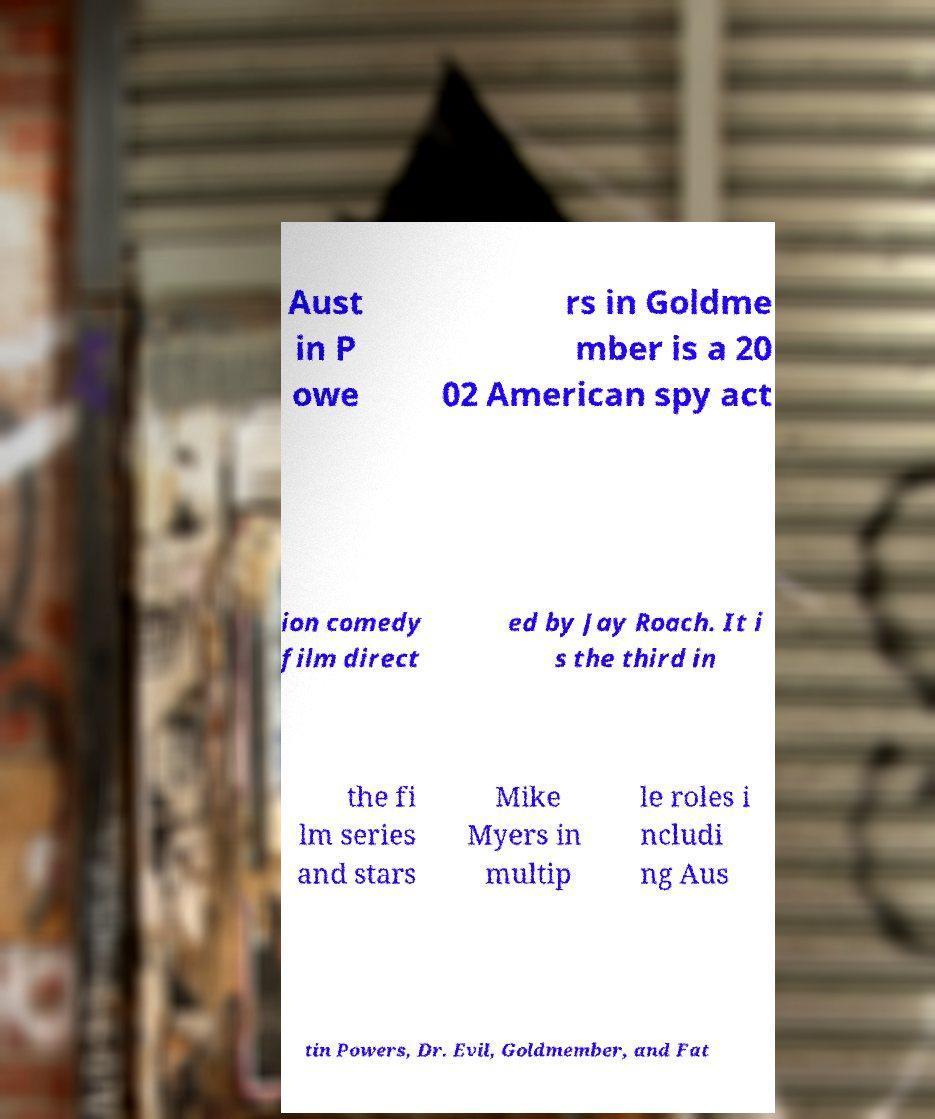Please read and relay the text visible in this image. What does it say? Aust in P owe rs in Goldme mber is a 20 02 American spy act ion comedy film direct ed by Jay Roach. It i s the third in the fi lm series and stars Mike Myers in multip le roles i ncludi ng Aus tin Powers, Dr. Evil, Goldmember, and Fat 